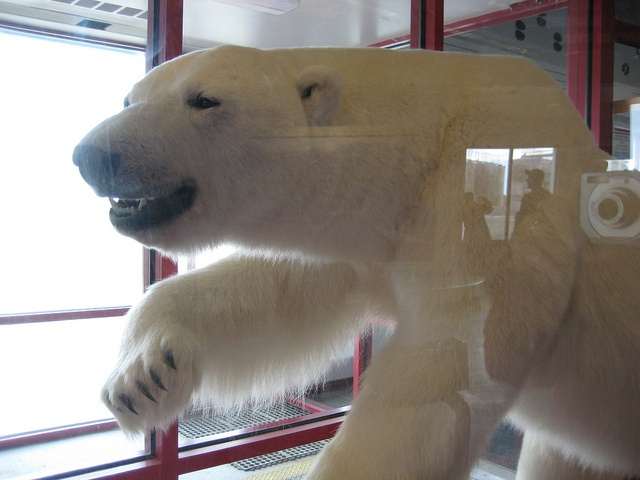Describe the objects in this image and their specific colors. I can see bear in gray, lightblue, and darkgray tones, people in lightblue, gray, and olive tones, people in lightblue and gray tones, and people in lightblue, gray, and olive tones in this image. 